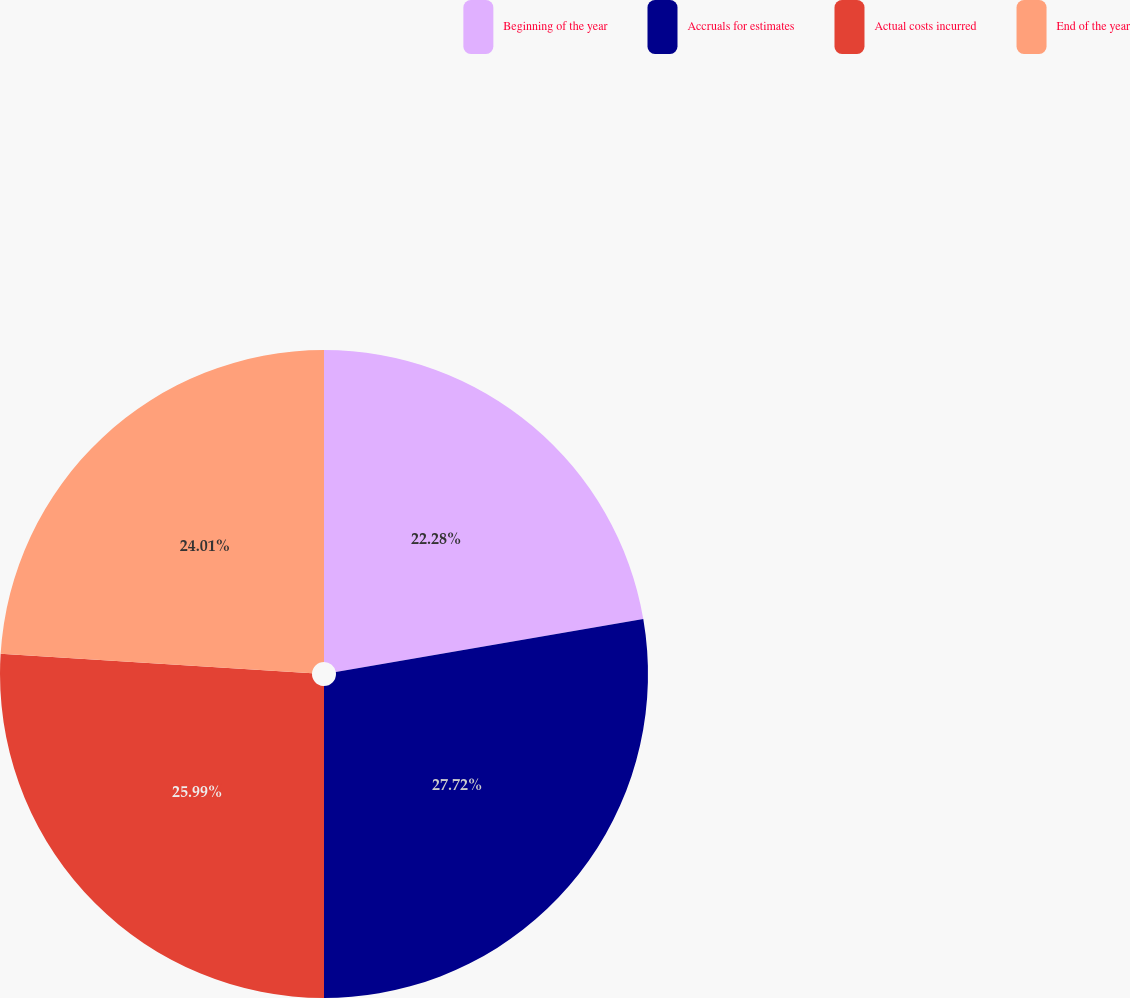Convert chart. <chart><loc_0><loc_0><loc_500><loc_500><pie_chart><fcel>Beginning of the year<fcel>Accruals for estimates<fcel>Actual costs incurred<fcel>End of the year<nl><fcel>22.28%<fcel>27.72%<fcel>25.99%<fcel>24.01%<nl></chart> 